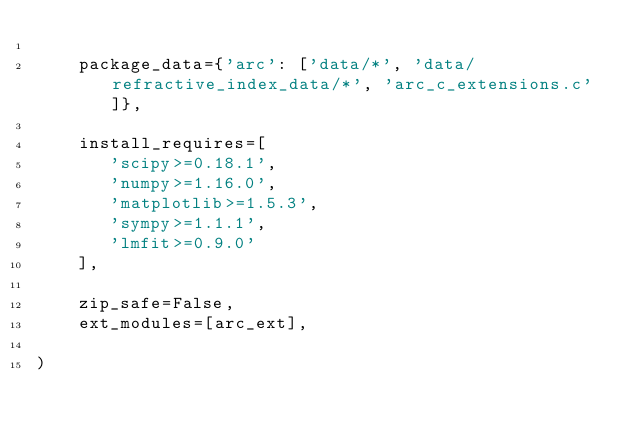<code> <loc_0><loc_0><loc_500><loc_500><_Python_>
    package_data={'arc': ['data/*', 'data/refractive_index_data/*', 'arc_c_extensions.c']},

    install_requires=[
       'scipy>=0.18.1',
       'numpy>=1.16.0',
       'matplotlib>=1.5.3',
       'sympy>=1.1.1',
       'lmfit>=0.9.0'
    ],

    zip_safe=False,
    ext_modules=[arc_ext],

)
</code> 